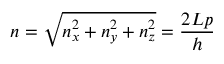<formula> <loc_0><loc_0><loc_500><loc_500>n = { \sqrt { n _ { x } ^ { 2 } + n _ { y } ^ { 2 } + n _ { z } ^ { 2 } } } = { \frac { 2 L p } { h } }</formula> 